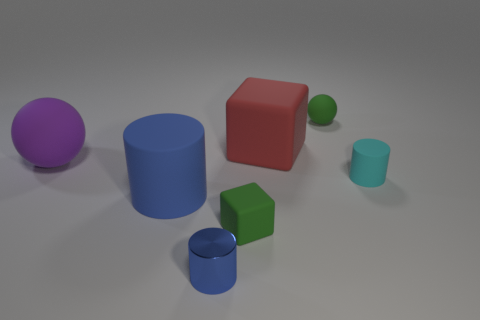Add 3 tiny matte cylinders. How many objects exist? 10 Subtract all yellow blocks. How many blue cylinders are left? 2 Subtract all blue cylinders. How many cylinders are left? 1 Subtract all spheres. How many objects are left? 5 Subtract 2 cylinders. How many cylinders are left? 1 Subtract all purple balls. How many balls are left? 1 Subtract 0 blue blocks. How many objects are left? 7 Subtract all green balls. Subtract all brown blocks. How many balls are left? 1 Subtract all large blue cylinders. Subtract all big purple objects. How many objects are left? 5 Add 1 large matte balls. How many large matte balls are left? 2 